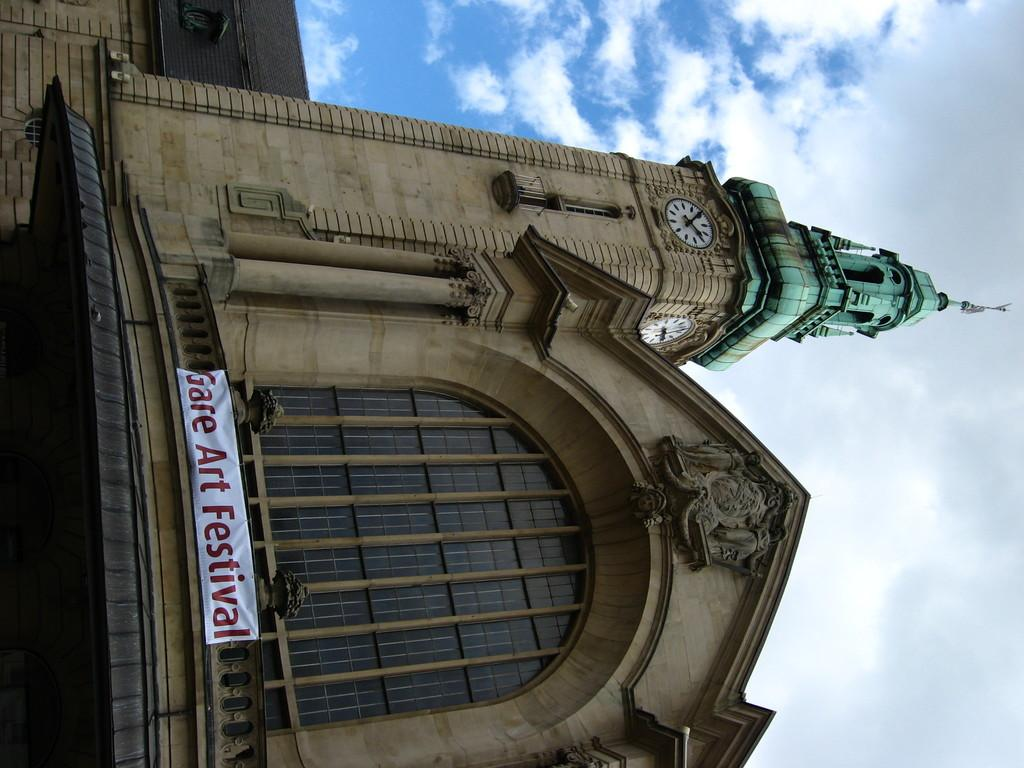What is the main structure in the image? There is a clock tower in the image. What else can be seen in the image besides the clock tower? There is a banner in the image. What is the condition of the sky in the background of the image? The sky is cloudy in the background of the image. What type of soup is being served in the image? There is no soup present in the image. Can you see a mitten hanging on the clock tower in the image? There is no mitten visible in the image. 